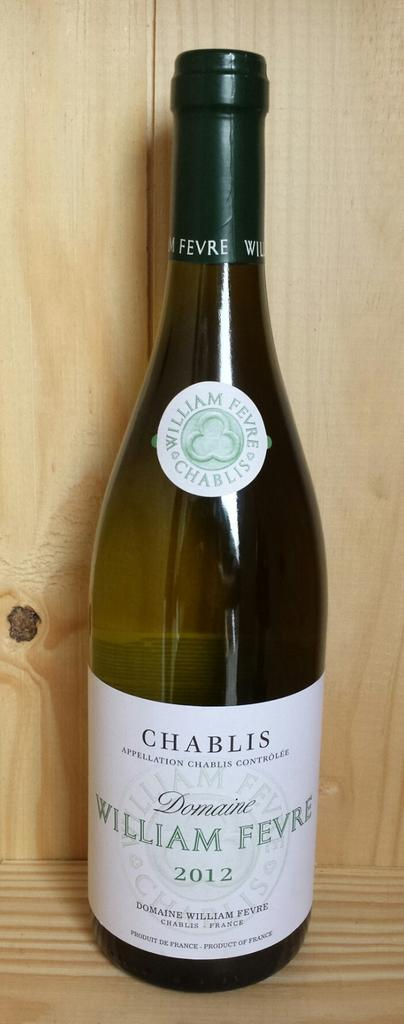<image>
Render a clear and concise summary of the photo. the word Chablis that is on a wine bottle 